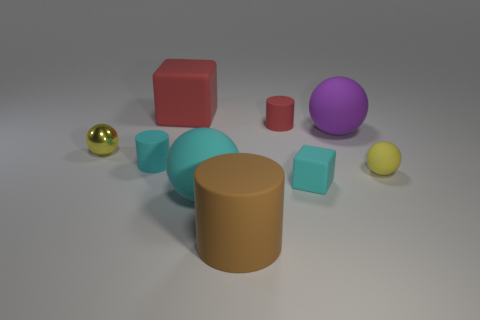Subtract all yellow spheres. How many were subtracted if there are1yellow spheres left? 1 Subtract all yellow rubber balls. How many balls are left? 3 Subtract all cyan cubes. How many cubes are left? 1 Subtract all blocks. How many objects are left? 7 Subtract all cyan spheres. How many red cubes are left? 1 Subtract 0 purple blocks. How many objects are left? 9 Subtract 3 cylinders. How many cylinders are left? 0 Subtract all green blocks. Subtract all blue cylinders. How many blocks are left? 2 Subtract all small cyan matte cylinders. Subtract all tiny metallic things. How many objects are left? 7 Add 4 large brown matte objects. How many large brown matte objects are left? 5 